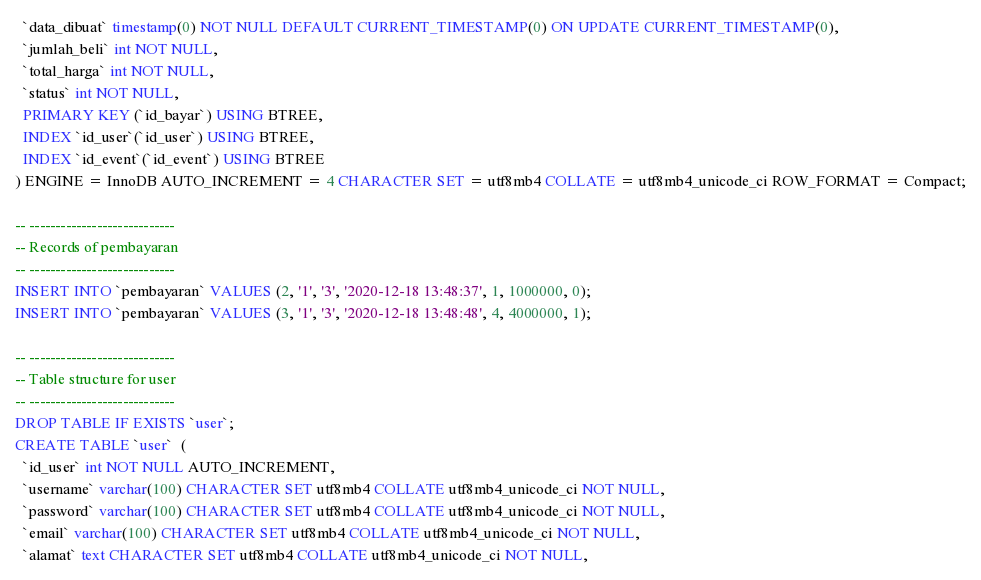<code> <loc_0><loc_0><loc_500><loc_500><_SQL_>  `data_dibuat` timestamp(0) NOT NULL DEFAULT CURRENT_TIMESTAMP(0) ON UPDATE CURRENT_TIMESTAMP(0),
  `jumlah_beli` int NOT NULL,
  `total_harga` int NOT NULL,
  `status` int NOT NULL,
  PRIMARY KEY (`id_bayar`) USING BTREE,
  INDEX `id_user`(`id_user`) USING BTREE,
  INDEX `id_event`(`id_event`) USING BTREE
) ENGINE = InnoDB AUTO_INCREMENT = 4 CHARACTER SET = utf8mb4 COLLATE = utf8mb4_unicode_ci ROW_FORMAT = Compact;

-- ----------------------------
-- Records of pembayaran
-- ----------------------------
INSERT INTO `pembayaran` VALUES (2, '1', '3', '2020-12-18 13:48:37', 1, 1000000, 0);
INSERT INTO `pembayaran` VALUES (3, '1', '3', '2020-12-18 13:48:48', 4, 4000000, 1);

-- ----------------------------
-- Table structure for user
-- ----------------------------
DROP TABLE IF EXISTS `user`;
CREATE TABLE `user`  (
  `id_user` int NOT NULL AUTO_INCREMENT,
  `username` varchar(100) CHARACTER SET utf8mb4 COLLATE utf8mb4_unicode_ci NOT NULL,
  `password` varchar(100) CHARACTER SET utf8mb4 COLLATE utf8mb4_unicode_ci NOT NULL,
  `email` varchar(100) CHARACTER SET utf8mb4 COLLATE utf8mb4_unicode_ci NOT NULL,
  `alamat` text CHARACTER SET utf8mb4 COLLATE utf8mb4_unicode_ci NOT NULL,</code> 